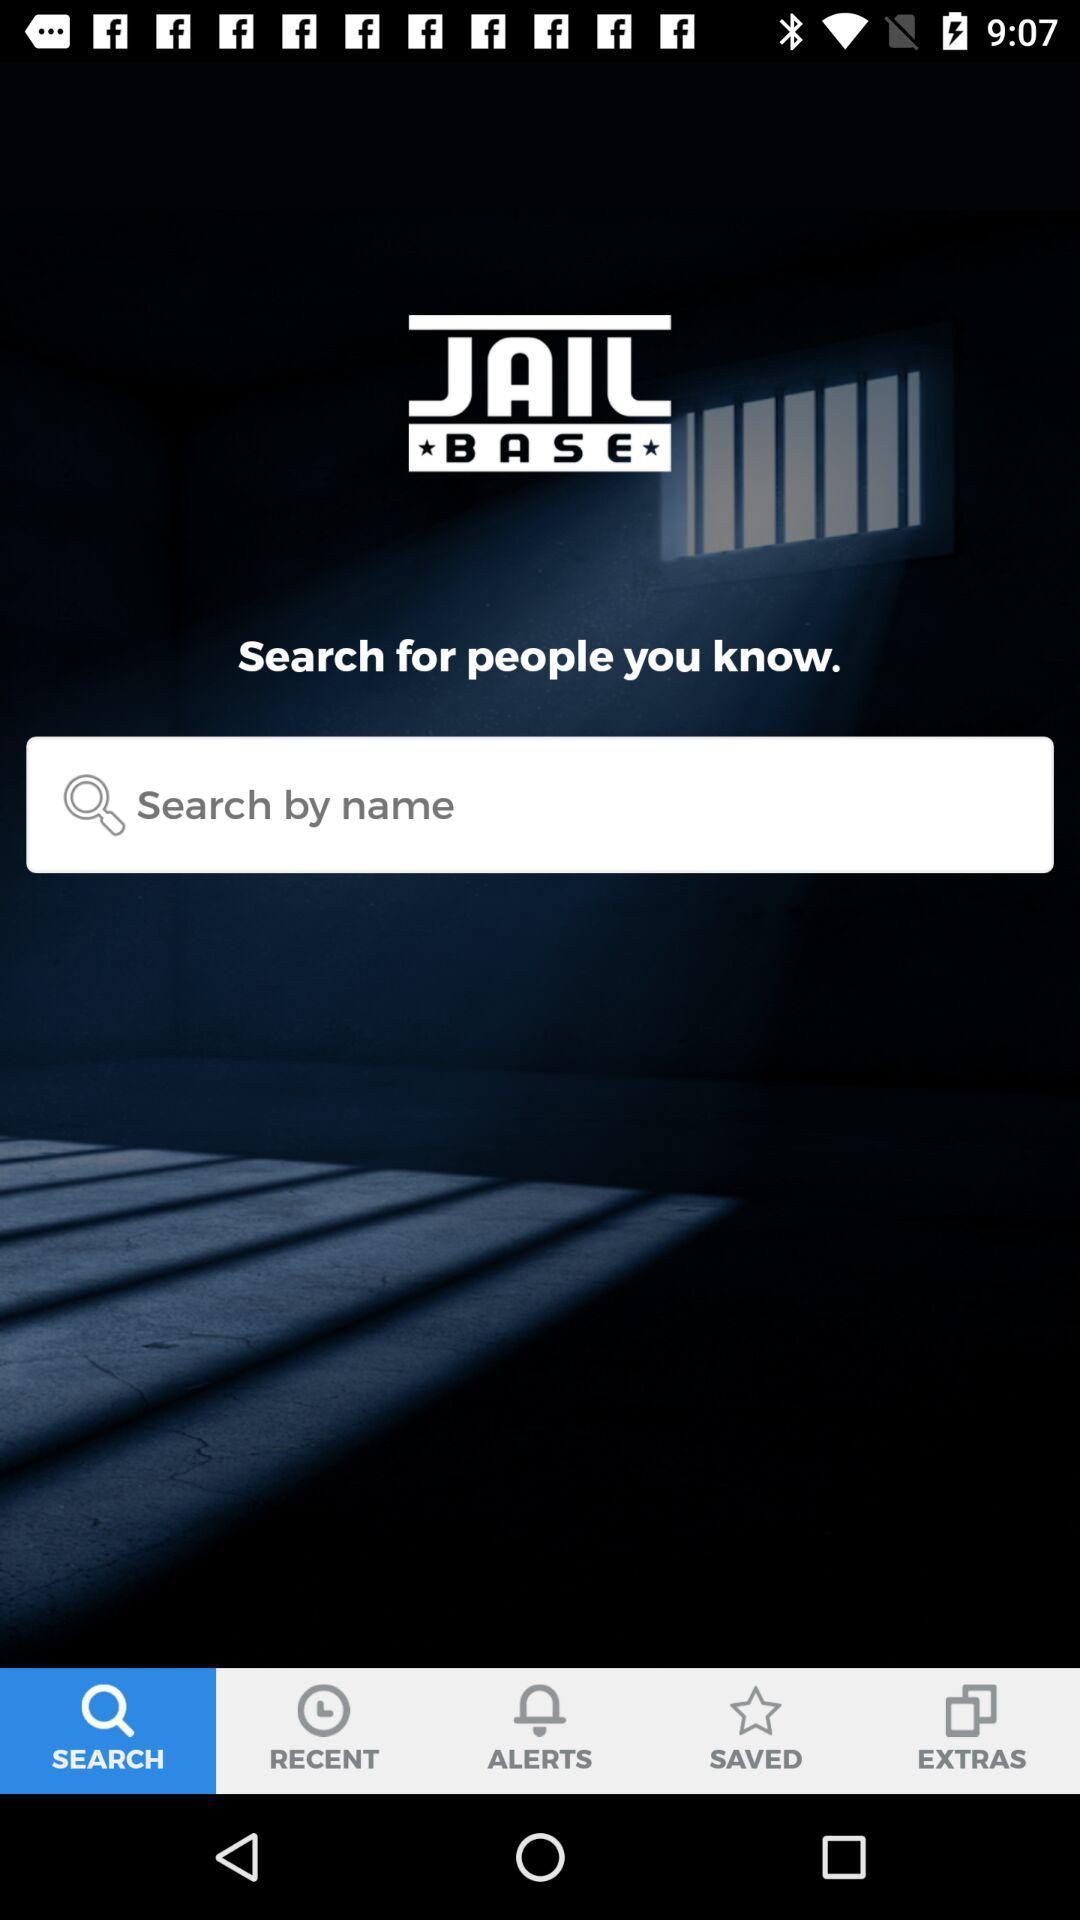What is the application name? The application name is "JailBase". 